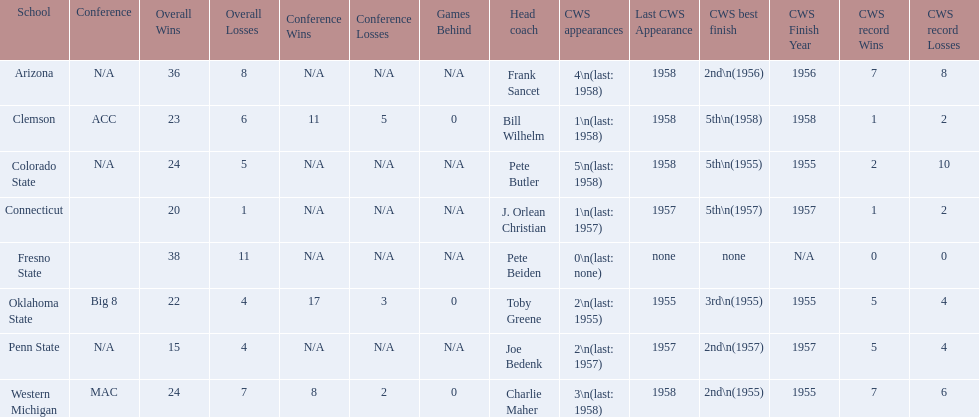What are the teams in the conference? Arizona, Clemson, Colorado State, Connecticut, Fresno State, Oklahoma State, Penn State, Western Michigan. Which have more than 16 wins? Arizona, Clemson, Colorado State, Connecticut, Fresno State, Oklahoma State, Western Michigan. Can you parse all the data within this table? {'header': ['School', 'Conference', 'Overall Wins', 'Overall Losses', 'Conference Wins', 'Conference Losses', 'Games Behind', 'Head coach', 'CWS appearances', 'Last CWS Appearance', 'CWS best finish', 'CWS Finish Year', 'CWS record Wins', 'CWS record Losses'], 'rows': [['Arizona', 'N/A', '36', '8', 'N/A', 'N/A', 'N/A', 'Frank Sancet', '4\\n(last: 1958)', '1958', '2nd\\n(1956)', '1956', '7', '8'], ['Clemson', 'ACC', '23', '6', '11', '5', '0', 'Bill Wilhelm', '1\\n(last: 1958)', '1958', '5th\\n(1958)', '1958', '1', '2'], ['Colorado State', 'N/A', '24', '5', 'N/A', 'N/A', 'N/A', 'Pete Butler', '5\\n(last: 1958)', '1958', '5th\\n(1955)', '1955', '2', '10'], ['Connecticut', '', '20', '1', 'N/A', 'N/A', 'N/A', 'J. Orlean Christian', '1\\n(last: 1957)', '1957', '5th\\n(1957)', '1957', '1', '2'], ['Fresno State', '', '38', '11', 'N/A', 'N/A', 'N/A', 'Pete Beiden', '0\\n(last: none)', 'none', 'none', 'N/A', '0', '0'], ['Oklahoma State', 'Big 8', '22', '4', '17', '3', '0', 'Toby Greene', '2\\n(last: 1955)', '1955', '3rd\\n(1955)', '1955', '5', '4'], ['Penn State', 'N/A', '15', '4', 'N/A', 'N/A', 'N/A', 'Joe Bedenk', '2\\n(last: 1957)', '1957', '2nd\\n(1957)', '1957', '5', '4'], ['Western Michigan', 'MAC', '24', '7', '8', '2', '0', 'Charlie Maher', '3\\n(last: 1958)', '1958', '2nd\\n(1955)', '1955', '7', '6']]} Which had less than 16 wins? Penn State. 